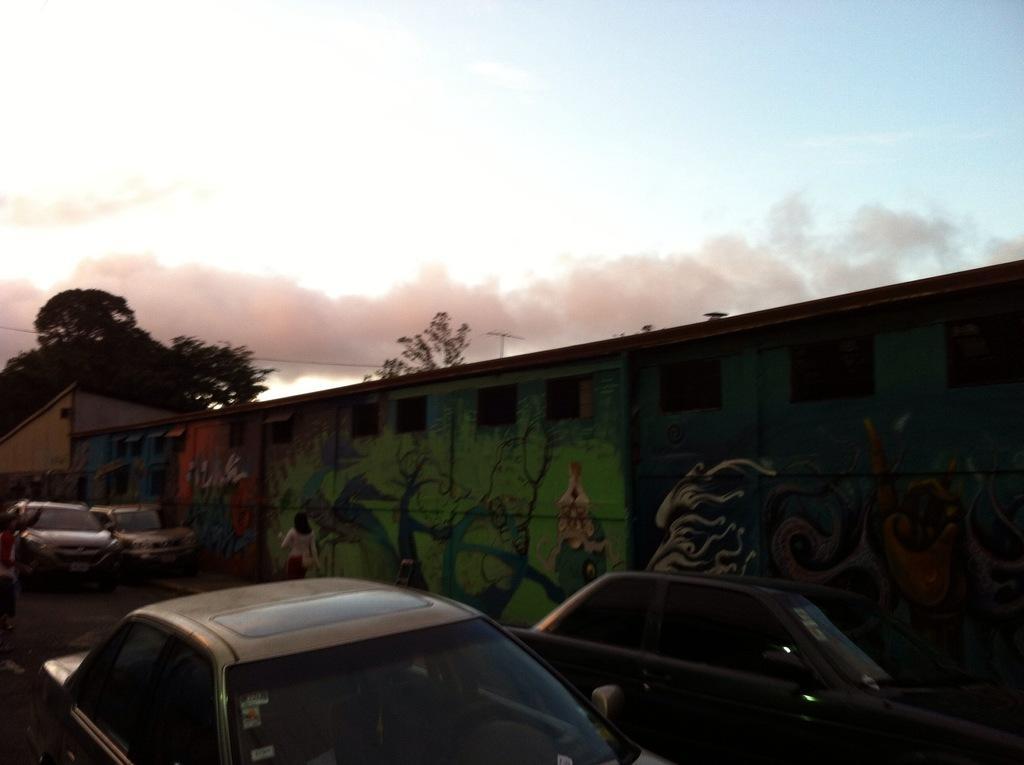In one or two sentences, can you explain what this image depicts? In the foreground of this image, there are vehicles on the road. Behind it, there are graffiti paintings on the wall and also a woman walking on the side path. We can also see trees and the sky in the background. 